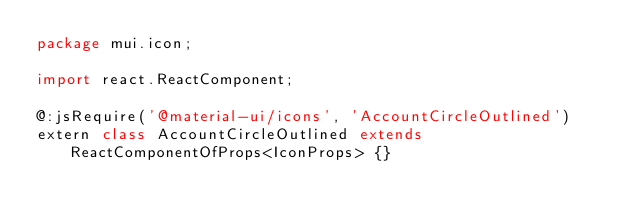<code> <loc_0><loc_0><loc_500><loc_500><_Haxe_>package mui.icon;

import react.ReactComponent;

@:jsRequire('@material-ui/icons', 'AccountCircleOutlined')
extern class AccountCircleOutlined extends ReactComponentOfProps<IconProps> {}
</code> 